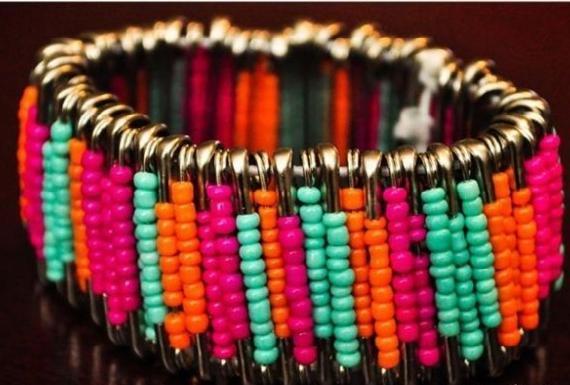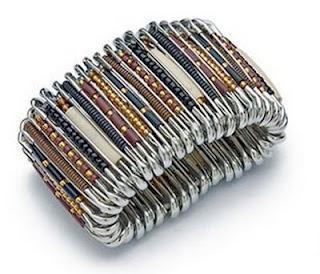The first image is the image on the left, the second image is the image on the right. For the images displayed, is the sentence "In one image, a bracelet made out of safety pins and blue and silver beads is on the arm of a person." factually correct? Answer yes or no. No. The first image is the image on the left, the second image is the image on the right. Considering the images on both sides, is "A bracelet is worn by a person." valid? Answer yes or no. No. 